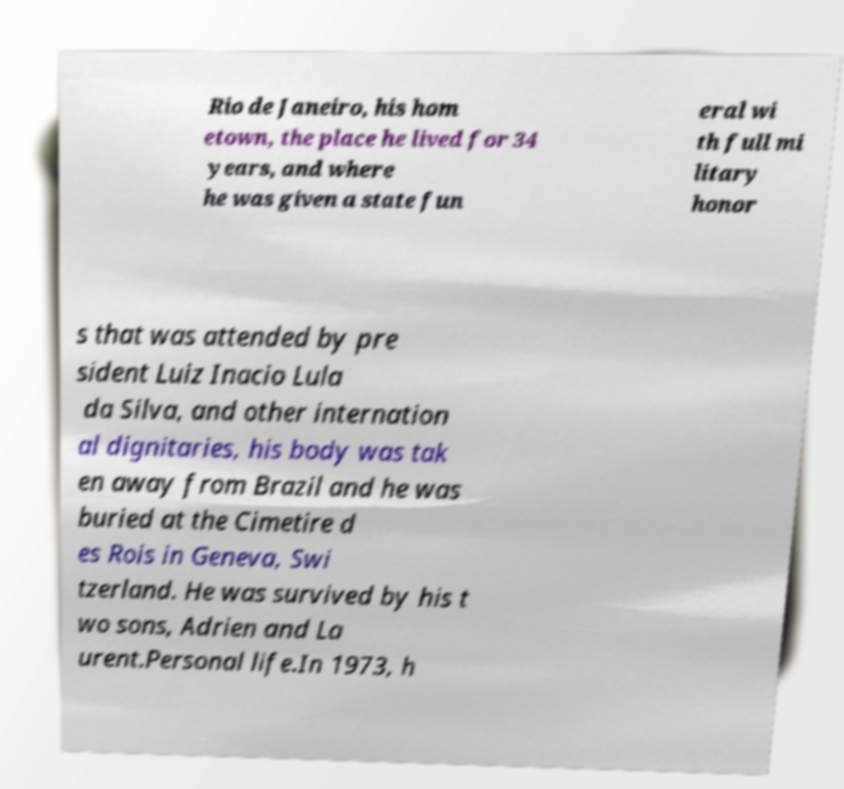Can you read and provide the text displayed in the image?This photo seems to have some interesting text. Can you extract and type it out for me? Rio de Janeiro, his hom etown, the place he lived for 34 years, and where he was given a state fun eral wi th full mi litary honor s that was attended by pre sident Luiz Inacio Lula da Silva, and other internation al dignitaries, his body was tak en away from Brazil and he was buried at the Cimetire d es Rois in Geneva, Swi tzerland. He was survived by his t wo sons, Adrien and La urent.Personal life.In 1973, h 